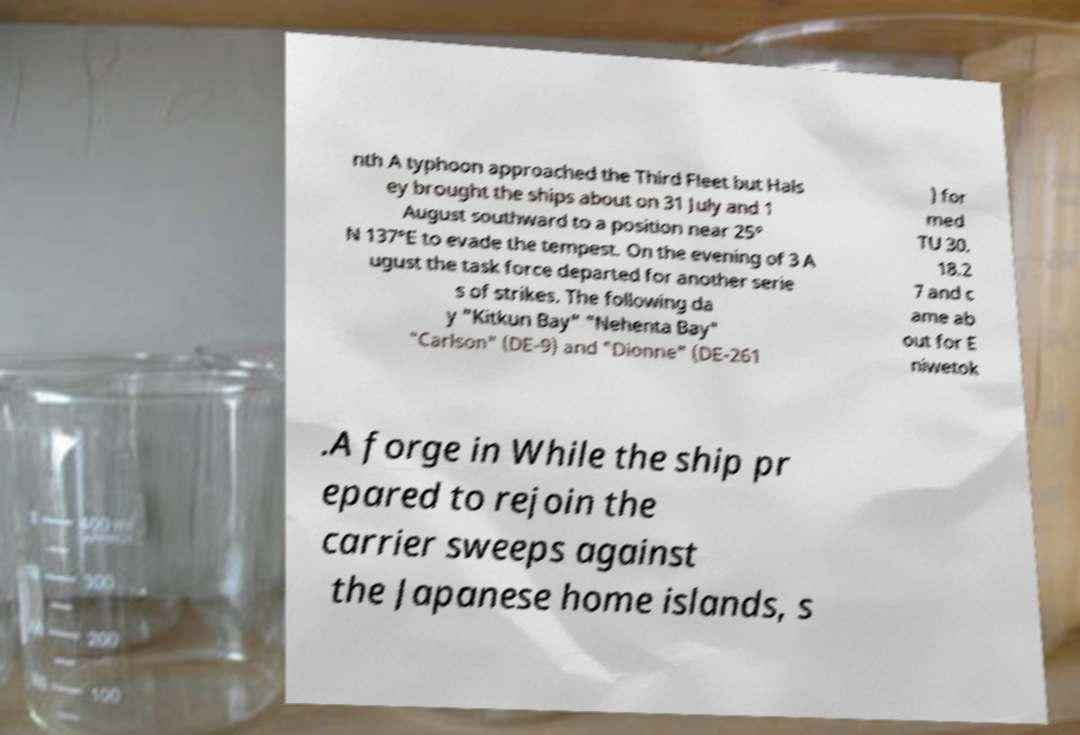I need the written content from this picture converted into text. Can you do that? nth A typhoon approached the Third Fleet but Hals ey brought the ships about on 31 July and 1 August southward to a position near 25° N 137°E to evade the tempest. On the evening of 3 A ugust the task force departed for another serie s of strikes. The following da y "Kitkun Bay" "Nehenta Bay" "Carlson" (DE-9) and "Dionne" (DE-261 ) for med TU 30. 18.2 7 and c ame ab out for E niwetok .A forge in While the ship pr epared to rejoin the carrier sweeps against the Japanese home islands, s 